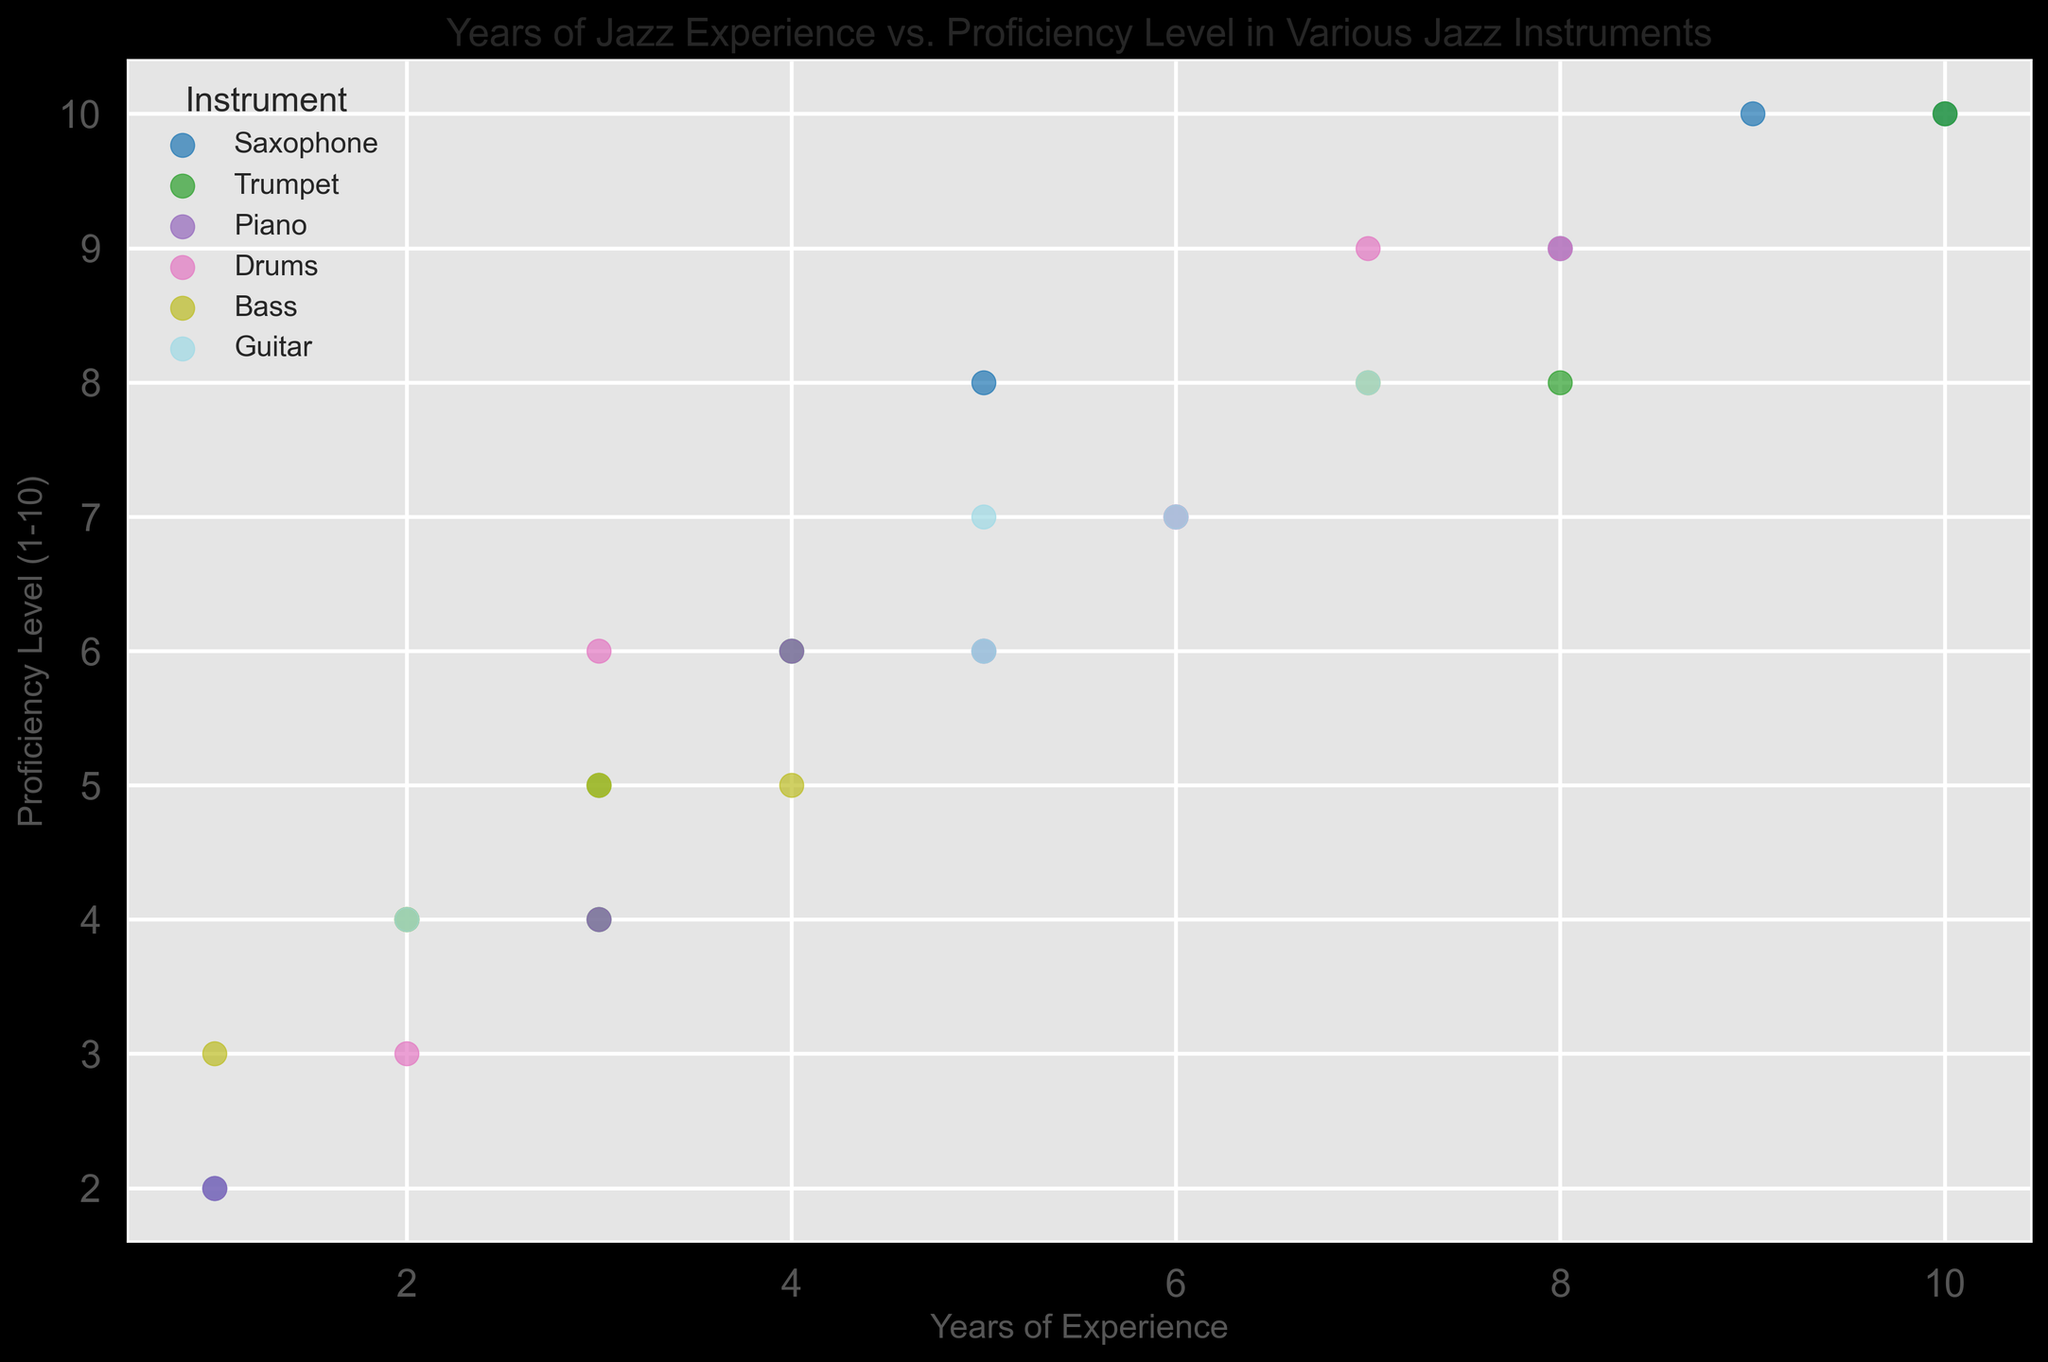What is the range of proficiency levels for saxophone players? To determine the range, find the lowest and highest proficiency levels for saxophone players. The data shows saxophone players have proficiency levels of 2, 8, 10, and 10. The range is 10 - 2 = 8.
Answer: 8 Which instrument has the most entries in the scatter plot? Count the number of occurrences for each instrument. Saxophone has 5, Trumpet has 6, Piano has 5, Drums has 5, Bass has 5, and Guitar has 5. Trumpet has the most entries.
Answer: Trumpet How many instruments have a maximum proficiency level of 10? Locate the points where the proficiency level is 10 and identify the instruments: Saxophone, Trumpet, and Saxophone. There are 3 points, but two belong to Saxophone. So, there are 2 distinct instruments: Saxophone and Trumpet.
Answer: 2 Which instrument shows the highest average proficiency level? Calculate the average proficiency level for each instrument: Saxophone (2+8+10+10+9)/5 = 7.8, Trumpet (4+8+6+10+5+10)/6 = 7.17, Piano (6+4+7+6+2)/5 = 5, Drums (3+9+7+9+6)/5 = 6.8, Bass (5+3+4+8+5)/5 = 5, Guitar (7+8+7+7)/4 = 7.25. Saxophone has the highest average proficiency level.
Answer: Saxophone What is the average proficiency level for musicians with 5 years of experience? Find the proficiency levels for various instruments at 5 years of experience: Piano (6), Saxophone (8), Guitar (7), Bass (5). The average is (6+8+7+5)/4 = 6.5.
Answer: 6.5 How many musicians with exactly 10 years of experience are there, and what instruments do they play? Identify the entries with 10 years of experience: Saxophone and Trumpet with proficiency levels of 10. There are 2 musicians with 10 years of experience.
Answer: 2, Saxophone and Trumpet Compare the proficiency levels between trumpet and guitar players with the same number of years of experience. Which group tends to have higher proficiency? Compare proficiency levels: For 3 years (Trumpet 4, Guitar N/A), 5 years (Trumpet 6, Guitar 7), 7 years (Trumpet N/A, Guitar 8), 10 years (Trumpet 10, Guitar N/A), etc. Generally, guitar players tend to have higher proficiency when comparing directly.
Answer: Guitar Which instrument shows the greatest improvement in proficiency level relative to years of experience? Compare slopes (change in proficiency / change in years) for each instrument. E.g., Saxophone (10-2)/(10-1) = 8/9 ≈ 0.89, Trumpet (10-4)/(10-3) = 6/7 ≈ 0.86, etc. Saxophone shows the greatest improvement.
Answer: Saxophone 